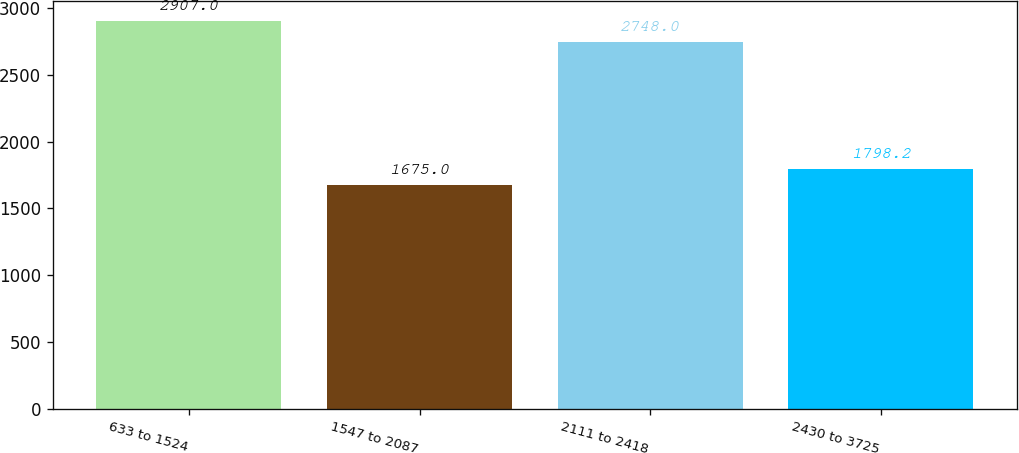Convert chart. <chart><loc_0><loc_0><loc_500><loc_500><bar_chart><fcel>633 to 1524<fcel>1547 to 2087<fcel>2111 to 2418<fcel>2430 to 3725<nl><fcel>2907<fcel>1675<fcel>2748<fcel>1798.2<nl></chart> 